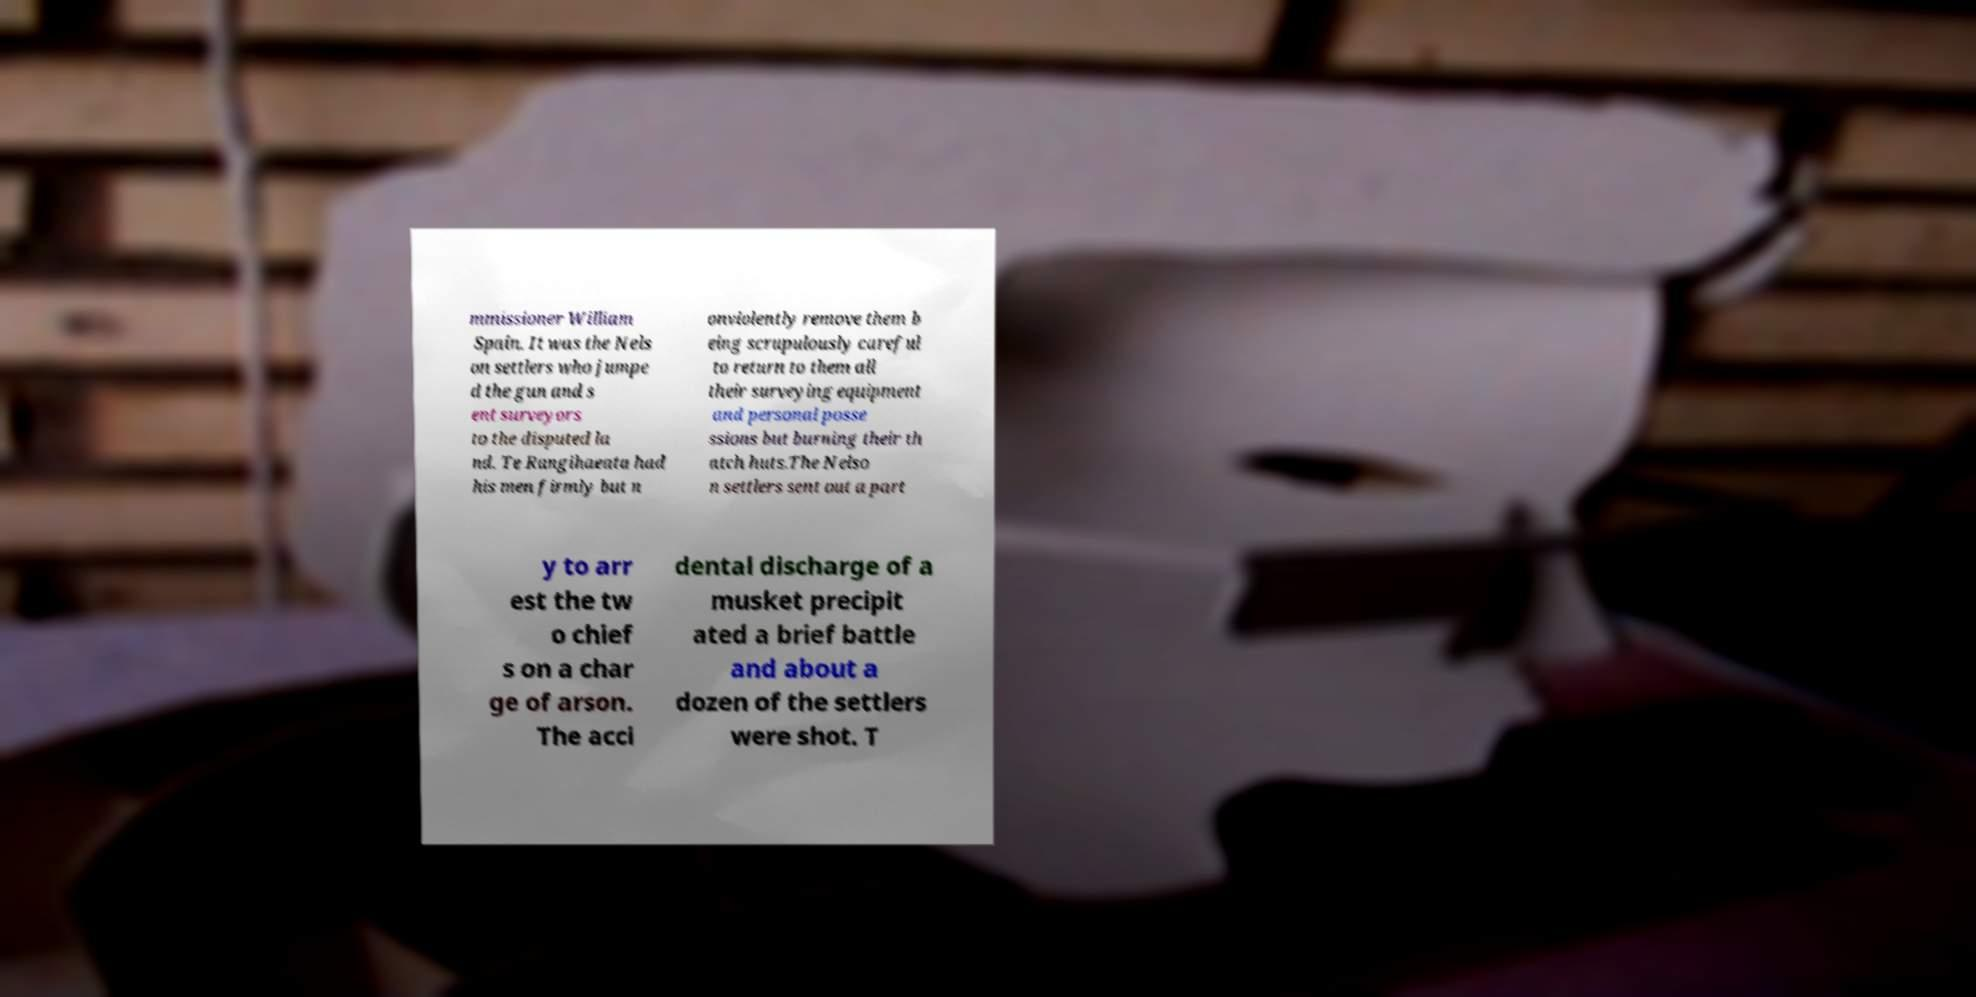What messages or text are displayed in this image? I need them in a readable, typed format. mmissioner William Spain. It was the Nels on settlers who jumpe d the gun and s ent surveyors to the disputed la nd. Te Rangihaeata had his men firmly but n onviolently remove them b eing scrupulously careful to return to them all their surveying equipment and personal posse ssions but burning their th atch huts.The Nelso n settlers sent out a part y to arr est the tw o chief s on a char ge of arson. The acci dental discharge of a musket precipit ated a brief battle and about a dozen of the settlers were shot. T 